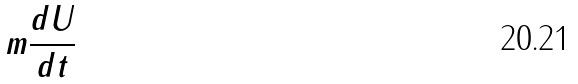<formula> <loc_0><loc_0><loc_500><loc_500>m \frac { d U } { d t }</formula> 